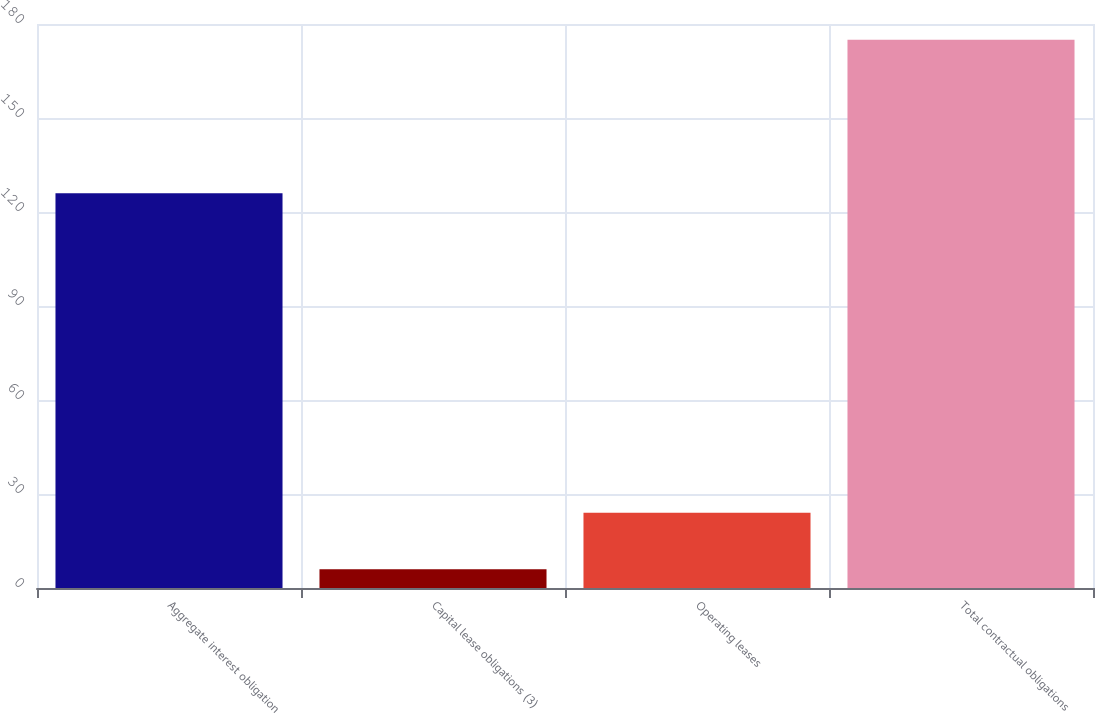Convert chart. <chart><loc_0><loc_0><loc_500><loc_500><bar_chart><fcel>Aggregate interest obligation<fcel>Capital lease obligations (3)<fcel>Operating leases<fcel>Total contractual obligations<nl><fcel>126<fcel>6<fcel>24<fcel>175<nl></chart> 